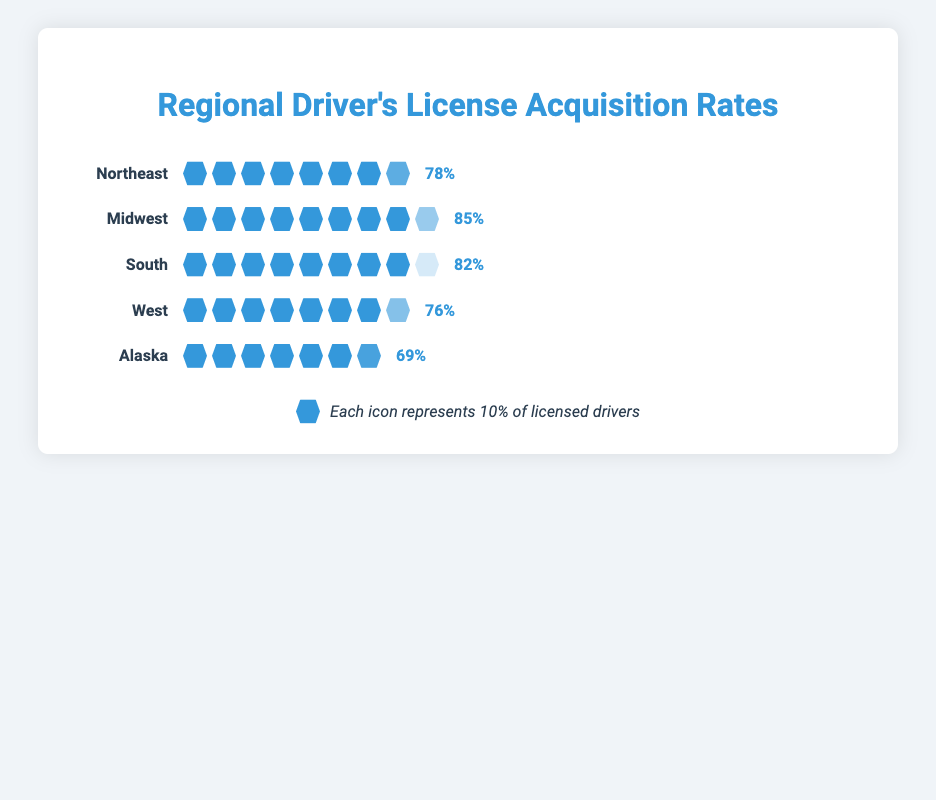what is the driver's license acquisition rate in the Northeast region? The Northeast region's rate can be directly observed on the plot where the license rate is marked next to the icon representation for the Northeast region.
Answer: 78% How many regions have a driver's license acquisition rate above 80%? To find the number of regions above 80%, examine the license rates next to each region's icon display in the plot. Midwest (85%), South (82%) are above 80%.
Answer: 2 Which region has the highest driver's license acquisition rate? The highest rate can be found by comparing the license rates next to the icon displays for each region. The Midwest region has the highest rate with 85%.
Answer: Midwest What's the difference in driver's license acquisition rates between the Midwest and Alaska? To find the difference, subtract Alaska's rate (69%) from the Midwest's rate (85%). The difference is 85% - 69%.
Answer: 16% What is the total driver's license acquisition rate for the Northeast and South regions combined? Add the acquisition rates of Northeast (78%) and South (82%) to get the combined rate. 78% + 82% = 160%.
Answer: 160% Which region has the lowest driver's license acquisition rate? The lowest rate can be found by comparing the license rates next to the icon displays for each region. Alaska has the lowest rate with 69%.
Answer: Alaska How does the Midwest’s rate compare to the West’s rate? To compare these rates, observe their values next to their icon displays: Midwest (85%) and West (76%). The Midwest has a higher rate.
Answer: Midwest has a higher rate If one icon represents 10% of licensed drivers, how many full icons represent the Northeast region? The Northeast has a rate of 78%. Since each icon represents 10%, divide 78 by 10. Only consider the full icons, which are 7.
Answer: 7 full icons What is the average driver's license acquisition rate across all regions shown? First, sum all license rates: 78% + 85% + 82% + 76% + 69%. The sum is 390%. Divide by the number of regions (5) to get the average. 390% / 5 = 78%.
Answer: 78% Given that each icon represents 10%, how many icons and what opacity is used to represent the license rate for the South region? For the South (82%), divide 82 by 10 to get 8 full icons and calculate the last icon's opacity as 2/10 = 0.2.
Answer: 8 icons and 0.2 opacity 